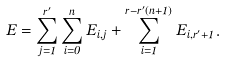Convert formula to latex. <formula><loc_0><loc_0><loc_500><loc_500>E = \sum _ { j = 1 } ^ { r ^ { \prime } } \sum _ { i = 0 } ^ { n } E _ { i , j } + \sum _ { i = 1 } ^ { r - r ^ { \prime } ( n + 1 ) } E _ { i , r ^ { \prime } + 1 } .</formula> 